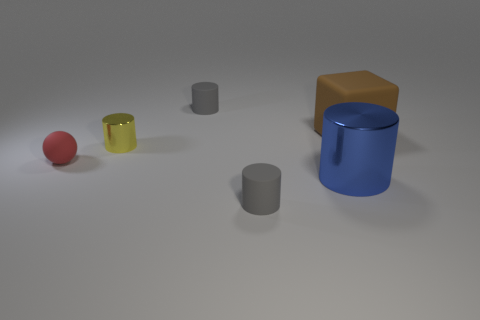Add 2 tiny red matte objects. How many objects exist? 8 Subtract 4 cylinders. How many cylinders are left? 0 Subtract all gray rubber things. Subtract all red objects. How many objects are left? 3 Add 3 large blue metal objects. How many large blue metal objects are left? 4 Add 4 large yellow metal cylinders. How many large yellow metal cylinders exist? 4 Subtract all gray cylinders. How many cylinders are left? 2 Subtract all big cylinders. How many cylinders are left? 3 Subtract 1 yellow cylinders. How many objects are left? 5 Subtract all blocks. How many objects are left? 5 Subtract all gray blocks. Subtract all blue balls. How many blocks are left? 1 